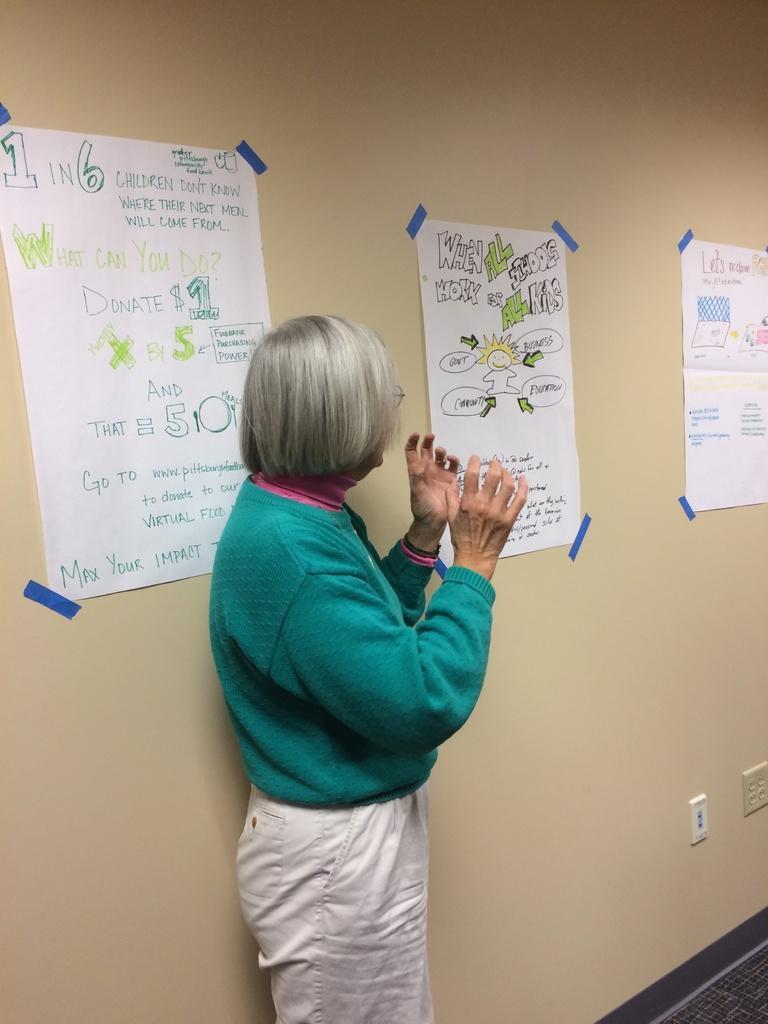In one or two sentences, can you explain what this image depicts? In the picture we can see woman wearing green color sweater, white color pant standing near the wall to which some charts are attached and there are some switch sockets. 